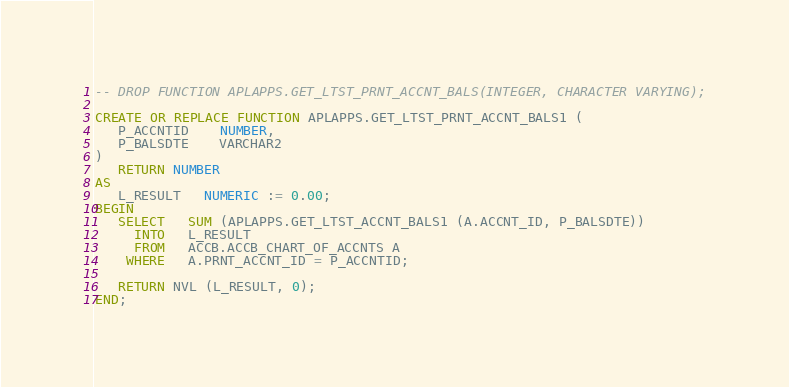Convert code to text. <code><loc_0><loc_0><loc_500><loc_500><_SQL_>-- DROP FUNCTION APLAPPS.GET_LTST_PRNT_ACCNT_BALS(INTEGER, CHARACTER VARYING);

CREATE OR REPLACE FUNCTION APLAPPS.GET_LTST_PRNT_ACCNT_BALS1 (
   P_ACCNTID    NUMBER,
   P_BALSDTE    VARCHAR2
)
   RETURN NUMBER
AS
   L_RESULT   NUMERIC := 0.00;
BEGIN
   SELECT   SUM (APLAPPS.GET_LTST_ACCNT_BALS1 (A.ACCNT_ID, P_BALSDTE))
     INTO   L_RESULT
     FROM   ACCB.ACCB_CHART_OF_ACCNTS A
    WHERE   A.PRNT_ACCNT_ID = P_ACCNTID;

   RETURN NVL (L_RESULT, 0);
END;</code> 